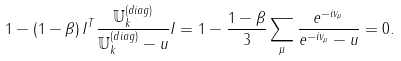Convert formula to latex. <formula><loc_0><loc_0><loc_500><loc_500>1 - ( 1 - \beta ) \, { I } ^ { T } \frac { \mathbb { U } _ { k } ^ { ( d i a g ) } } { \mathbb { U } _ { k } ^ { ( d i a g ) } - u } { I } = 1 - \frac { 1 - \beta } { 3 } \sum _ { \mu } \frac { e ^ { - i v _ { \mu } } } { e ^ { - i v _ { \mu } } - u } = 0 .</formula> 